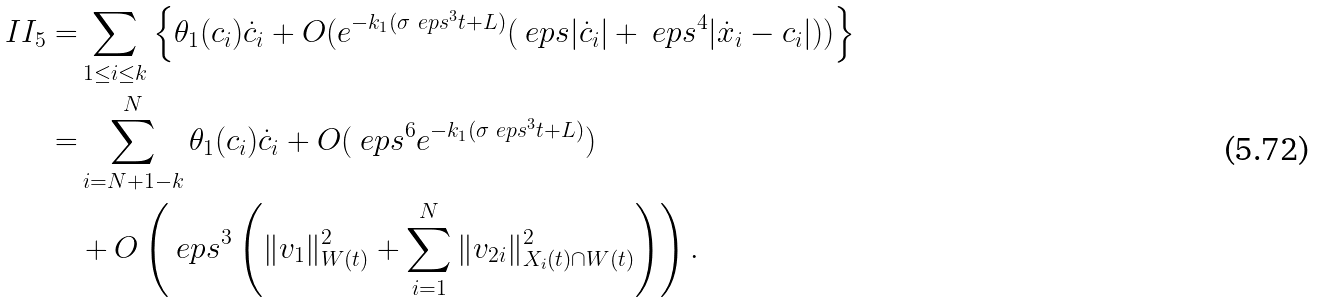<formula> <loc_0><loc_0><loc_500><loc_500>I I _ { 5 } = & \sum _ { 1 \leq i \leq k } \left \{ \theta _ { 1 } ( c _ { i } ) \dot { c } _ { i } + O ( e ^ { - k _ { 1 } ( \sigma \ e p s ^ { 3 } t + L ) } ( \ e p s | \dot { c } _ { i } | + \ e p s ^ { 4 } | \dot { x } _ { i } - c _ { i } | ) ) \right \} \\ = & \sum _ { i = N + 1 - k } ^ { N } \theta _ { 1 } ( c _ { i } ) \dot { c } _ { i } + O ( \ e p s ^ { 6 } e ^ { - k _ { 1 } ( \sigma \ e p s ^ { 3 } t + L ) } ) \\ & + O \left ( \ e p s ^ { 3 } \left ( \| v _ { 1 } \| _ { W ( t ) } ^ { 2 } + \sum _ { i = 1 } ^ { N } \| v _ { 2 i } \| _ { X _ { i } ( t ) \cap W ( t ) } ^ { 2 } \right ) \right ) .</formula> 